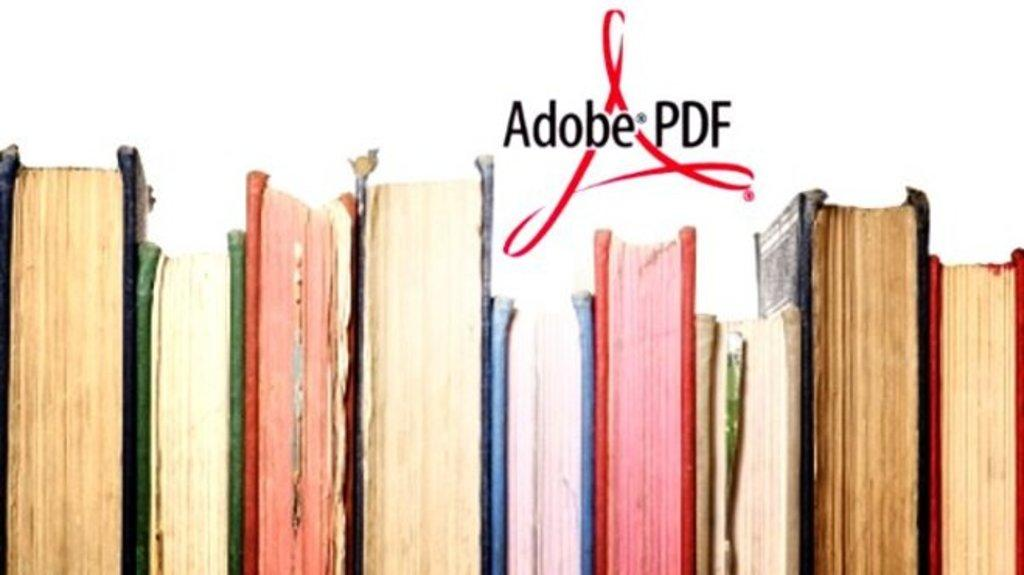<image>
Create a compact narrative representing the image presented. Several books are placed with their spines away from view with the Adobe PDF logo above them. 